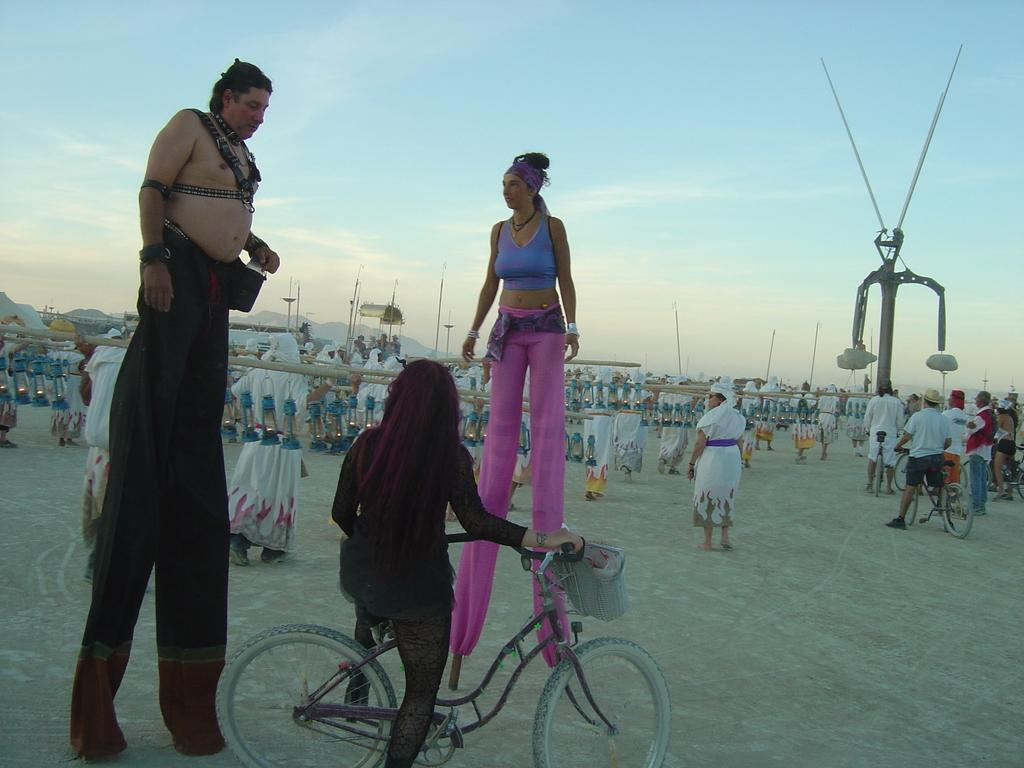How many people are in the image? There is a group of people in the image. What are two people doing in the image? Two people are standing on a stick. What can be seen behind the group of people? The sky is visible at the back of the group. What type of transport can be seen in the image? There is no transport visible in the image. What is the visibility like in the image? The visibility is not mentioned in the image, but the sky is visible at the back of the group. 